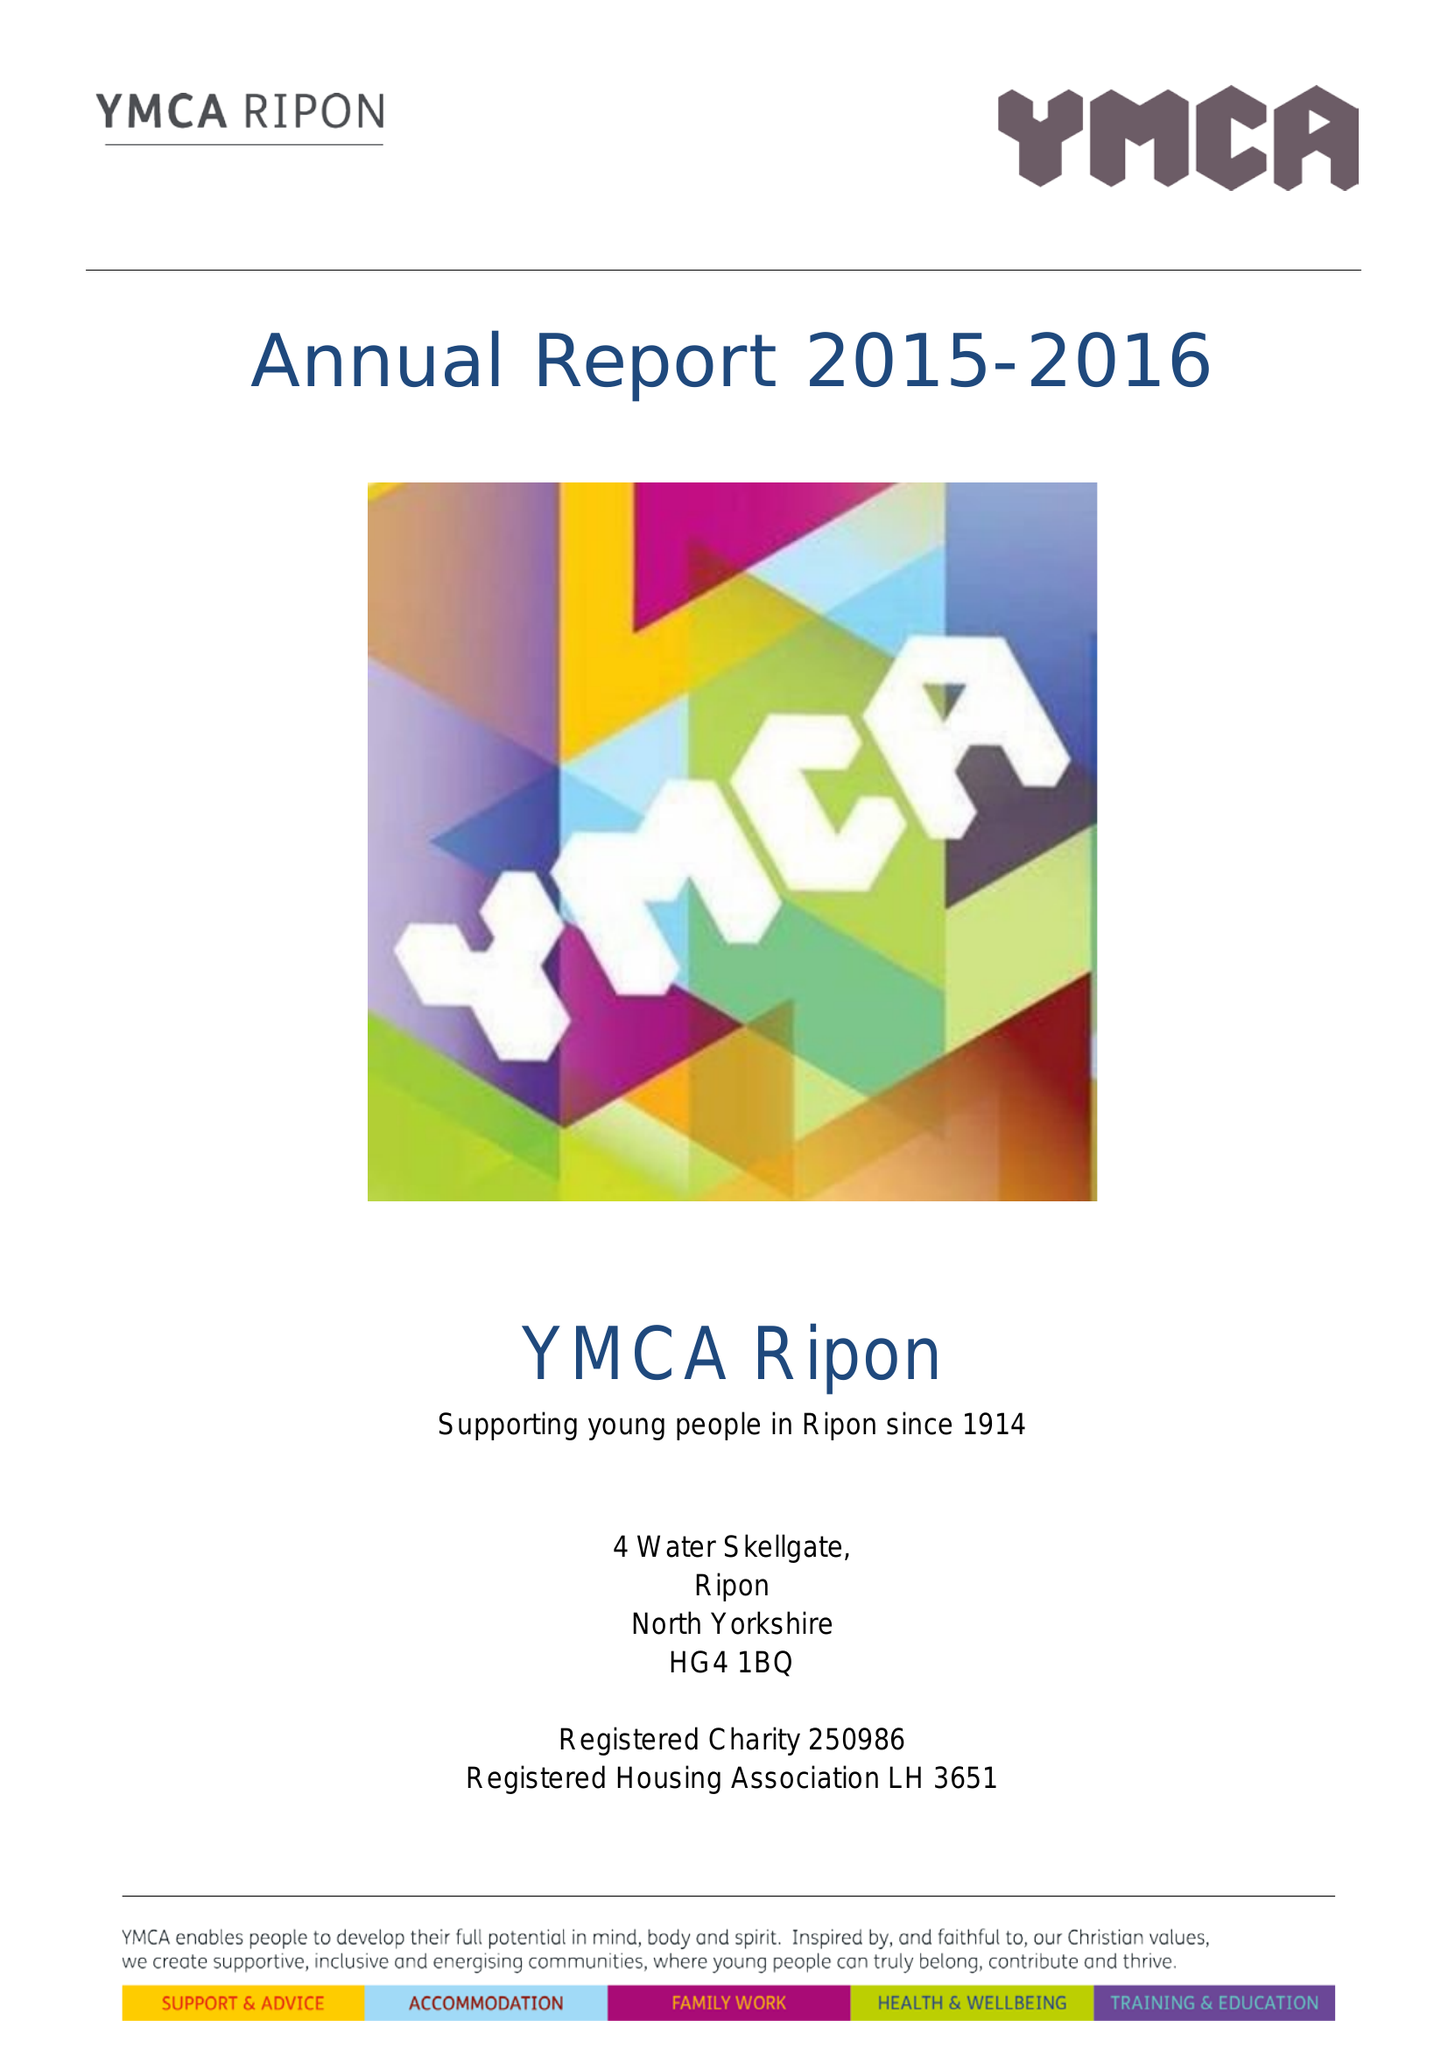What is the value for the income_annually_in_british_pounds?
Answer the question using a single word or phrase. 139054.00 